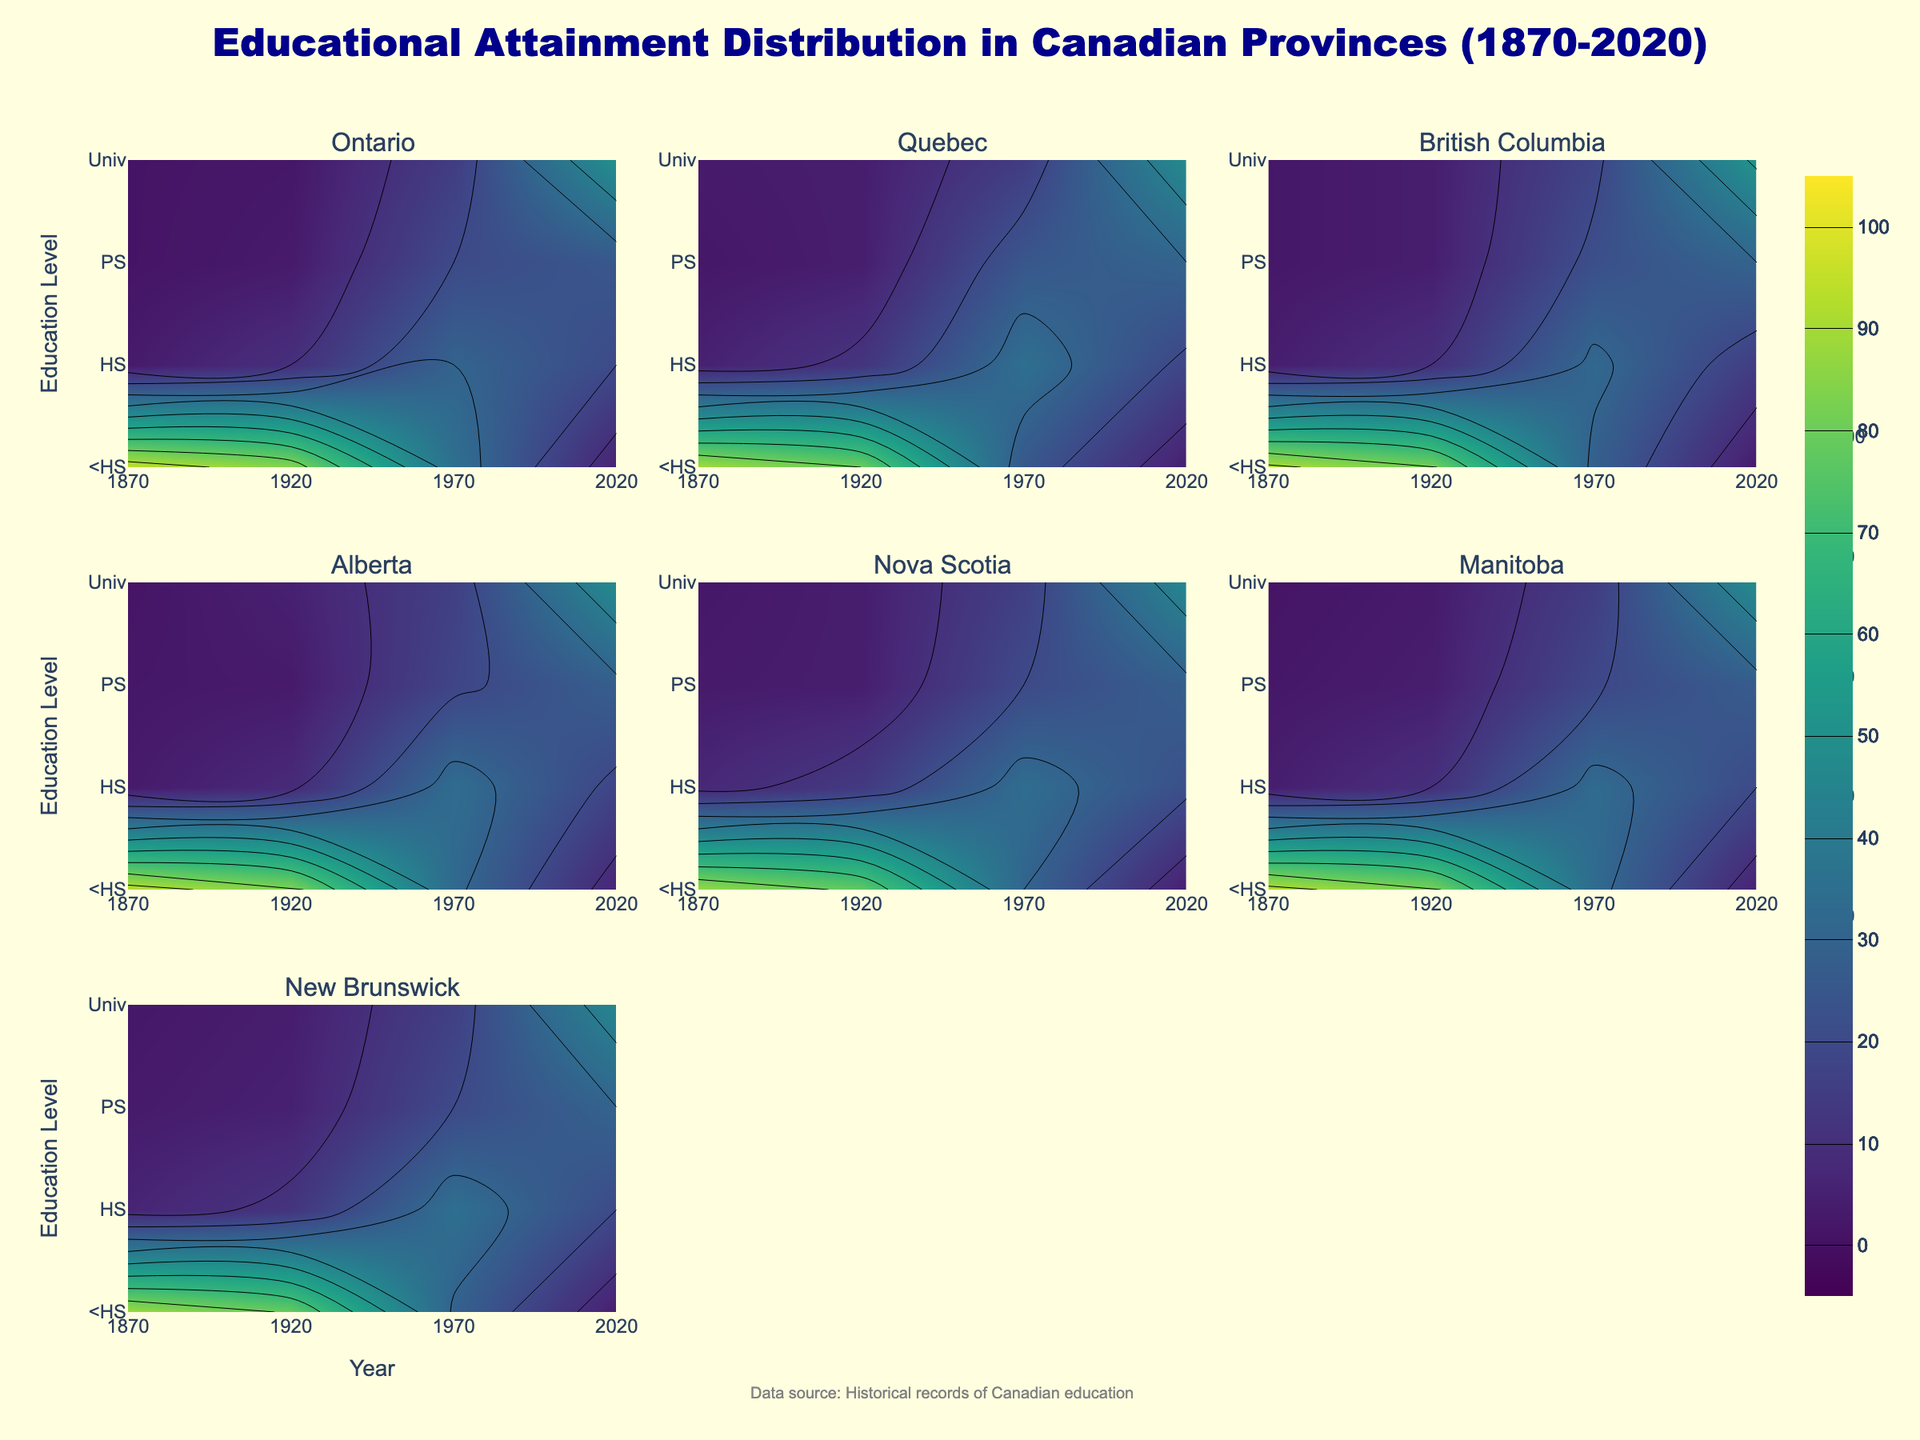Which province shows the highest percentage of individuals with a university education in 2020? Looking at the contours for each province in the year 2020, British Columbia shows the highest peak at the "University" level, indicating over 50%.
Answer: British Columbia What is the average percentage of individuals with less than high school education in 1920 across all provinces? To find the average, add the values from each province for 1920 (Ontario: 85, Quebec: 80, British Columbia: 82, Alberta: 84, Nova Scotia: 78, Manitoba: 83, New Brunswick: 79) and divide by the number of provinces (7). This gives (85+80+82+84+78+83+79)/7 = 81.57.
Answer: 81.57 How does the educational attainment trend in Quebec from 1870 to 2020 compare to Ontario? Comparing the trends, both provinces show a significant decrease in the "Less_than_High_School" category and increases in higher education levels. However, Quebec consistently has a higher percentage in the "Postsecondary_Non_University" level post-1970 compared to Ontario.
Answer: Similar trend, but Quebec has higher percentages in postsecondary non-university education post-1970 Which province witnessed the smallest decrease in the percentage of individuals with less than high school education from 1870 to 2020? By comparing the start and end values for "Less_than_High_School" for each province, Quebec shows the smallest decrease, going from 90 in 1870 to 4 in 2020, making a decrease of 86 percentage points.
Answer: Quebec What is the sum of the percentages of individuals with high school education in Ontario and Nova Scotia in 1970? Summing the "High_School" values for Ontario (30) and Nova Scotia (34) in 1970 gives 30 + 34 = 64.
Answer: 64 Which province experienced the most significant growth in university education from 1870 to 2020? Looking at the increase in the "University" category percentage from 1870 to 2020, Ontario has the highest growth, increasing from 1% in 1870 to 50% in 2020, a growth of 49 percentage points.
Answer: Ontario What is the percentage change in individuals with a postsecondary non-university education in Alberta from 1970 to 2020? Subtract the 1970 value (18%) from the 2020 value (28%) and divide by the 1970 value, then multiply by 100: ((28-18)/18) * 100 = 55.56%.
Answer: 55.56 What trend can be observed about high school education attainment across all provinces between 1920 and 1970? Observing the contours for the "High_School" category, all provinces exhibit an increasing trend during this period.
Answer: Increasing trend By what percentage did the university education level in Nova Scotia change from 1920 to 2020? Subtract the value in 1920 (4%) from the 2020 value (46%) to get the percentage change: 46% - 4% = 42%.
Answer: 42 